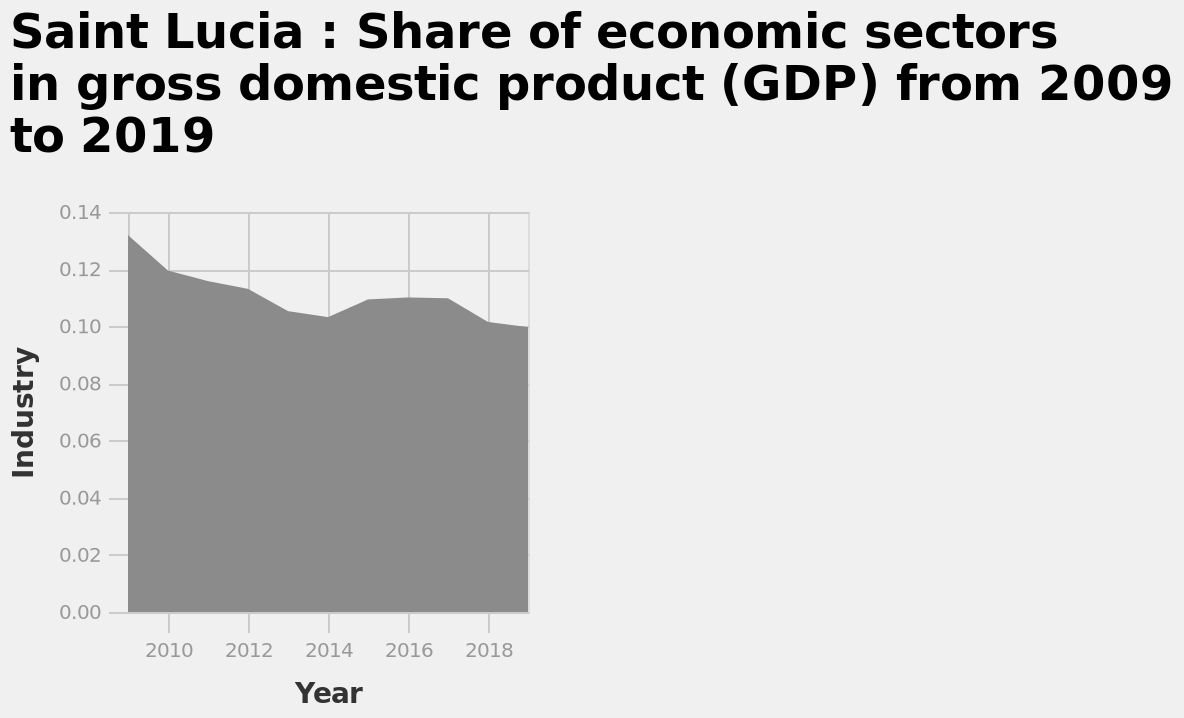<image>
How did the industry trend from 2015 to 2017?  From 2015 to 2017, the industry leveled out after a rise, maintaining a stable value. What is defined on the y-axis of the graph?  The y-axis of the graph represents "Industry." 